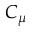Convert formula to latex. <formula><loc_0><loc_0><loc_500><loc_500>C _ { \mu }</formula> 